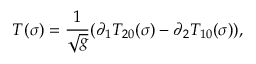<formula> <loc_0><loc_0><loc_500><loc_500>T ( \sigma ) = \frac { 1 } { \sqrt { g } } ( \partial _ { 1 } T _ { 2 0 } ( \sigma ) - \partial _ { 2 } T _ { 1 0 } ( \sigma ) ) ,</formula> 